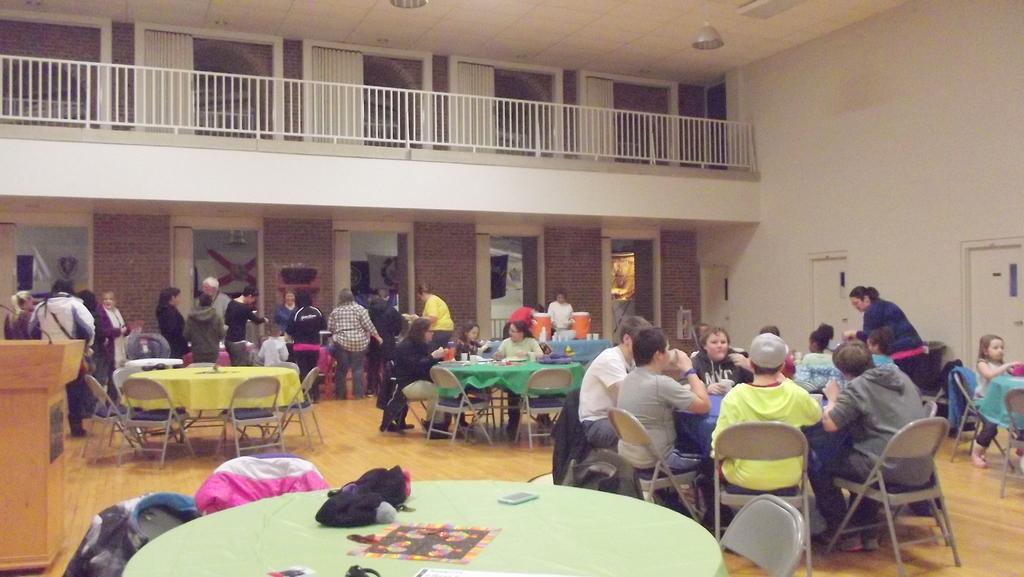Could you give a brief overview of what you see in this image? In this image there are group of people. There are phone, bag, bottles on the table. At the right side of the image the are two doors and at the top the there is a light, at the left there is a podium. 